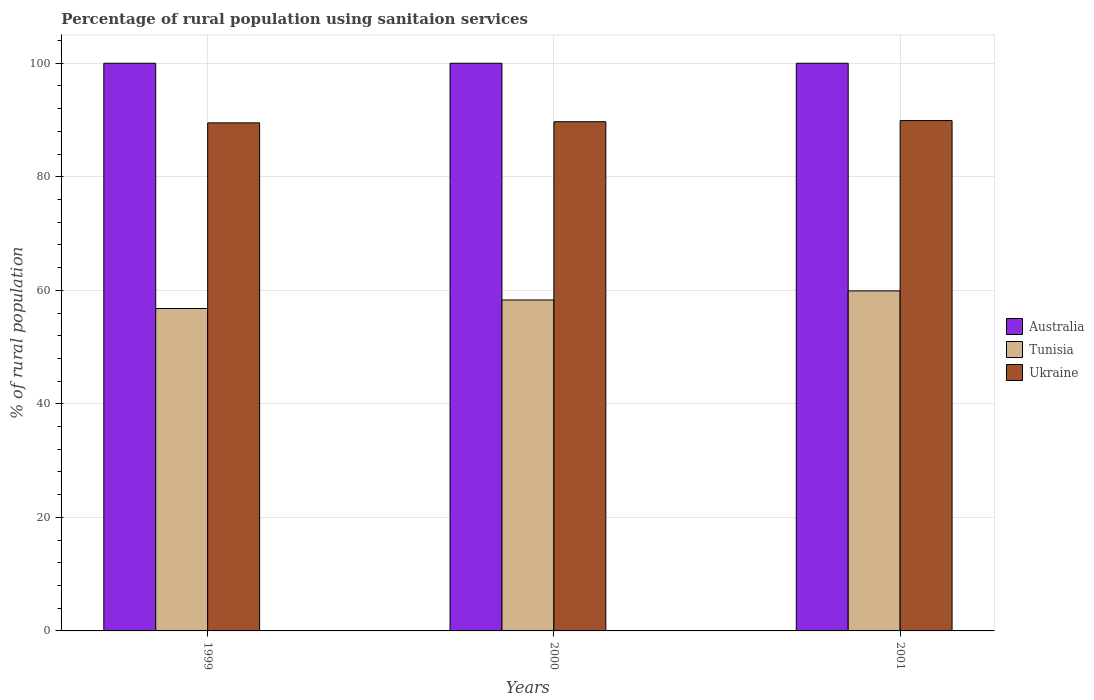Are the number of bars per tick equal to the number of legend labels?
Ensure brevity in your answer.  Yes. How many bars are there on the 3rd tick from the left?
Make the answer very short. 3. How many bars are there on the 3rd tick from the right?
Provide a succinct answer. 3. What is the percentage of rural population using sanitaion services in Tunisia in 2000?
Provide a succinct answer. 58.3. Across all years, what is the maximum percentage of rural population using sanitaion services in Ukraine?
Make the answer very short. 89.9. Across all years, what is the minimum percentage of rural population using sanitaion services in Ukraine?
Offer a very short reply. 89.5. In which year was the percentage of rural population using sanitaion services in Australia maximum?
Give a very brief answer. 1999. What is the total percentage of rural population using sanitaion services in Ukraine in the graph?
Your answer should be very brief. 269.1. What is the difference between the percentage of rural population using sanitaion services in Ukraine in 1999 and that in 2000?
Provide a succinct answer. -0.2. What is the difference between the percentage of rural population using sanitaion services in Australia in 2000 and the percentage of rural population using sanitaion services in Ukraine in 1999?
Ensure brevity in your answer.  10.5. What is the average percentage of rural population using sanitaion services in Australia per year?
Ensure brevity in your answer.  100. In the year 1999, what is the difference between the percentage of rural population using sanitaion services in Ukraine and percentage of rural population using sanitaion services in Australia?
Give a very brief answer. -10.5. In how many years, is the percentage of rural population using sanitaion services in Tunisia greater than 72 %?
Your answer should be compact. 0. What is the ratio of the percentage of rural population using sanitaion services in Tunisia in 1999 to that in 2000?
Your response must be concise. 0.97. Is the difference between the percentage of rural population using sanitaion services in Ukraine in 2000 and 2001 greater than the difference between the percentage of rural population using sanitaion services in Australia in 2000 and 2001?
Offer a terse response. No. What is the difference between the highest and the second highest percentage of rural population using sanitaion services in Tunisia?
Keep it short and to the point. 1.6. What is the difference between the highest and the lowest percentage of rural population using sanitaion services in Tunisia?
Provide a short and direct response. 3.1. Is the sum of the percentage of rural population using sanitaion services in Australia in 2000 and 2001 greater than the maximum percentage of rural population using sanitaion services in Ukraine across all years?
Offer a very short reply. Yes. What does the 2nd bar from the right in 2001 represents?
Offer a very short reply. Tunisia. How many bars are there?
Provide a short and direct response. 9. How many years are there in the graph?
Ensure brevity in your answer.  3. What is the difference between two consecutive major ticks on the Y-axis?
Ensure brevity in your answer.  20. Does the graph contain any zero values?
Your answer should be compact. No. How many legend labels are there?
Ensure brevity in your answer.  3. What is the title of the graph?
Make the answer very short. Percentage of rural population using sanitaion services. Does "Philippines" appear as one of the legend labels in the graph?
Provide a short and direct response. No. What is the label or title of the Y-axis?
Make the answer very short. % of rural population. What is the % of rural population in Tunisia in 1999?
Your answer should be very brief. 56.8. What is the % of rural population in Ukraine in 1999?
Give a very brief answer. 89.5. What is the % of rural population of Australia in 2000?
Provide a short and direct response. 100. What is the % of rural population in Tunisia in 2000?
Make the answer very short. 58.3. What is the % of rural population of Ukraine in 2000?
Give a very brief answer. 89.7. What is the % of rural population in Tunisia in 2001?
Offer a very short reply. 59.9. What is the % of rural population of Ukraine in 2001?
Your answer should be compact. 89.9. Across all years, what is the maximum % of rural population in Australia?
Ensure brevity in your answer.  100. Across all years, what is the maximum % of rural population of Tunisia?
Your answer should be compact. 59.9. Across all years, what is the maximum % of rural population in Ukraine?
Make the answer very short. 89.9. Across all years, what is the minimum % of rural population in Tunisia?
Your answer should be very brief. 56.8. Across all years, what is the minimum % of rural population of Ukraine?
Keep it short and to the point. 89.5. What is the total % of rural population of Australia in the graph?
Offer a very short reply. 300. What is the total % of rural population in Tunisia in the graph?
Your response must be concise. 175. What is the total % of rural population of Ukraine in the graph?
Your answer should be compact. 269.1. What is the difference between the % of rural population of Tunisia in 1999 and that in 2000?
Give a very brief answer. -1.5. What is the difference between the % of rural population in Australia in 1999 and that in 2001?
Your response must be concise. 0. What is the difference between the % of rural population in Tunisia in 1999 and that in 2001?
Provide a short and direct response. -3.1. What is the difference between the % of rural population in Ukraine in 1999 and that in 2001?
Provide a short and direct response. -0.4. What is the difference between the % of rural population in Australia in 1999 and the % of rural population in Tunisia in 2000?
Your answer should be very brief. 41.7. What is the difference between the % of rural population of Tunisia in 1999 and the % of rural population of Ukraine in 2000?
Offer a very short reply. -32.9. What is the difference between the % of rural population in Australia in 1999 and the % of rural population in Tunisia in 2001?
Provide a short and direct response. 40.1. What is the difference between the % of rural population of Tunisia in 1999 and the % of rural population of Ukraine in 2001?
Ensure brevity in your answer.  -33.1. What is the difference between the % of rural population of Australia in 2000 and the % of rural population of Tunisia in 2001?
Provide a short and direct response. 40.1. What is the difference between the % of rural population in Australia in 2000 and the % of rural population in Ukraine in 2001?
Make the answer very short. 10.1. What is the difference between the % of rural population in Tunisia in 2000 and the % of rural population in Ukraine in 2001?
Ensure brevity in your answer.  -31.6. What is the average % of rural population of Tunisia per year?
Provide a short and direct response. 58.33. What is the average % of rural population in Ukraine per year?
Provide a succinct answer. 89.7. In the year 1999, what is the difference between the % of rural population in Australia and % of rural population in Tunisia?
Ensure brevity in your answer.  43.2. In the year 1999, what is the difference between the % of rural population in Australia and % of rural population in Ukraine?
Offer a very short reply. 10.5. In the year 1999, what is the difference between the % of rural population in Tunisia and % of rural population in Ukraine?
Offer a very short reply. -32.7. In the year 2000, what is the difference between the % of rural population in Australia and % of rural population in Tunisia?
Your answer should be compact. 41.7. In the year 2000, what is the difference between the % of rural population of Tunisia and % of rural population of Ukraine?
Keep it short and to the point. -31.4. In the year 2001, what is the difference between the % of rural population of Australia and % of rural population of Tunisia?
Offer a terse response. 40.1. What is the ratio of the % of rural population in Tunisia in 1999 to that in 2000?
Your answer should be compact. 0.97. What is the ratio of the % of rural population in Ukraine in 1999 to that in 2000?
Offer a very short reply. 1. What is the ratio of the % of rural population of Australia in 1999 to that in 2001?
Ensure brevity in your answer.  1. What is the ratio of the % of rural population in Tunisia in 1999 to that in 2001?
Offer a very short reply. 0.95. What is the ratio of the % of rural population in Australia in 2000 to that in 2001?
Make the answer very short. 1. What is the ratio of the % of rural population of Tunisia in 2000 to that in 2001?
Make the answer very short. 0.97. What is the ratio of the % of rural population in Ukraine in 2000 to that in 2001?
Your answer should be compact. 1. What is the difference between the highest and the second highest % of rural population in Australia?
Provide a succinct answer. 0. What is the difference between the highest and the lowest % of rural population of Australia?
Keep it short and to the point. 0. What is the difference between the highest and the lowest % of rural population in Tunisia?
Provide a short and direct response. 3.1. 